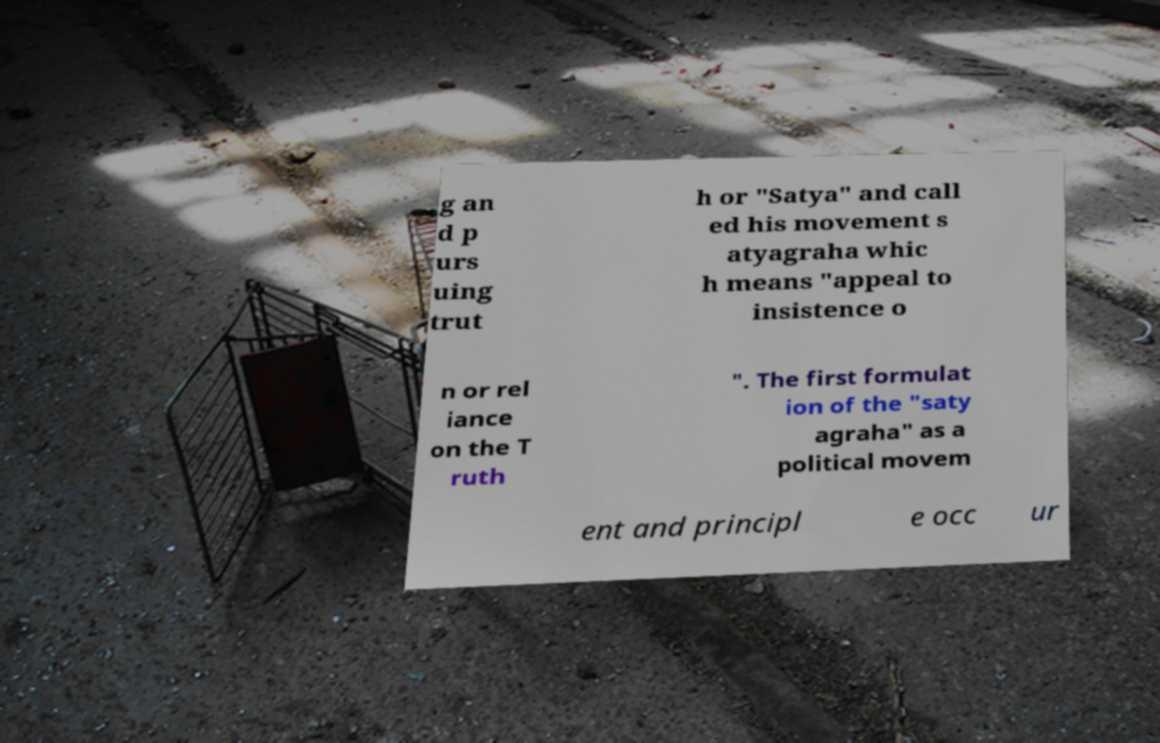I need the written content from this picture converted into text. Can you do that? g an d p urs uing trut h or "Satya" and call ed his movement s atyagraha whic h means "appeal to insistence o n or rel iance on the T ruth ". The first formulat ion of the "saty agraha" as a political movem ent and principl e occ ur 